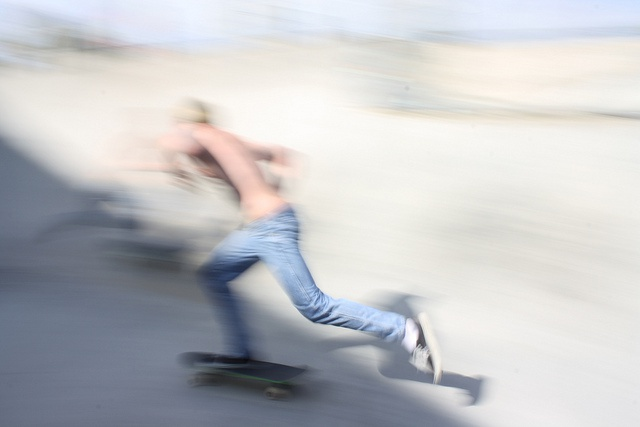Describe the objects in this image and their specific colors. I can see people in lavender, lightgray, lightblue, and darkgray tones and skateboard in lavender, black, gray, and purple tones in this image. 